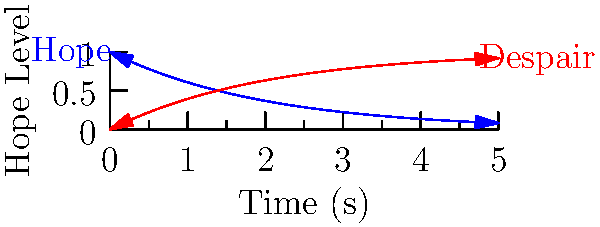In the vacuum of a writer's existential crisis, hope decays exponentially according to the function $H(t) = e^{-kt}$, where $H$ is the hope level, $t$ is time in seconds, and $k$ is the soul-crushing constant. If half of a writer's hope disappears in 2 seconds, at what rate (in hope units per second) does hope die in this literary void? Let's approach this with the dry wit of a resigned physicist:

1) We know that hope decays according to $H(t) = e^{-kt}$.

2) At $t = 2$ seconds, half of the hope is gone. Mathematically:
   $H(2) = \frac{1}{2} = e^{-k(2)}$

3) Taking the natural log of both sides:
   $\ln(\frac{1}{2}) = -2k$

4) Solving for $k$:
   $k = -\frac{\ln(\frac{1}{2})}{2} = \frac{\ln(2)}{2} \approx 0.3466$ per second

5) The rate at which hope dies is the negative derivative of $H(t)$:
   $\frac{dH}{dt} = -ke^{-kt}$

6) At $t = 0$ (when the existential crisis begins), this rate is:
   $\frac{dH}{dt}|_{t=0} = -k \cdot 1 = -0.3466$ hope units per second

Thus, hope dies at a rate of 0.3466 hope units per second, which is probably faster than our writer can type their despairing prose.
Answer: $0.3466$ hope units/second 